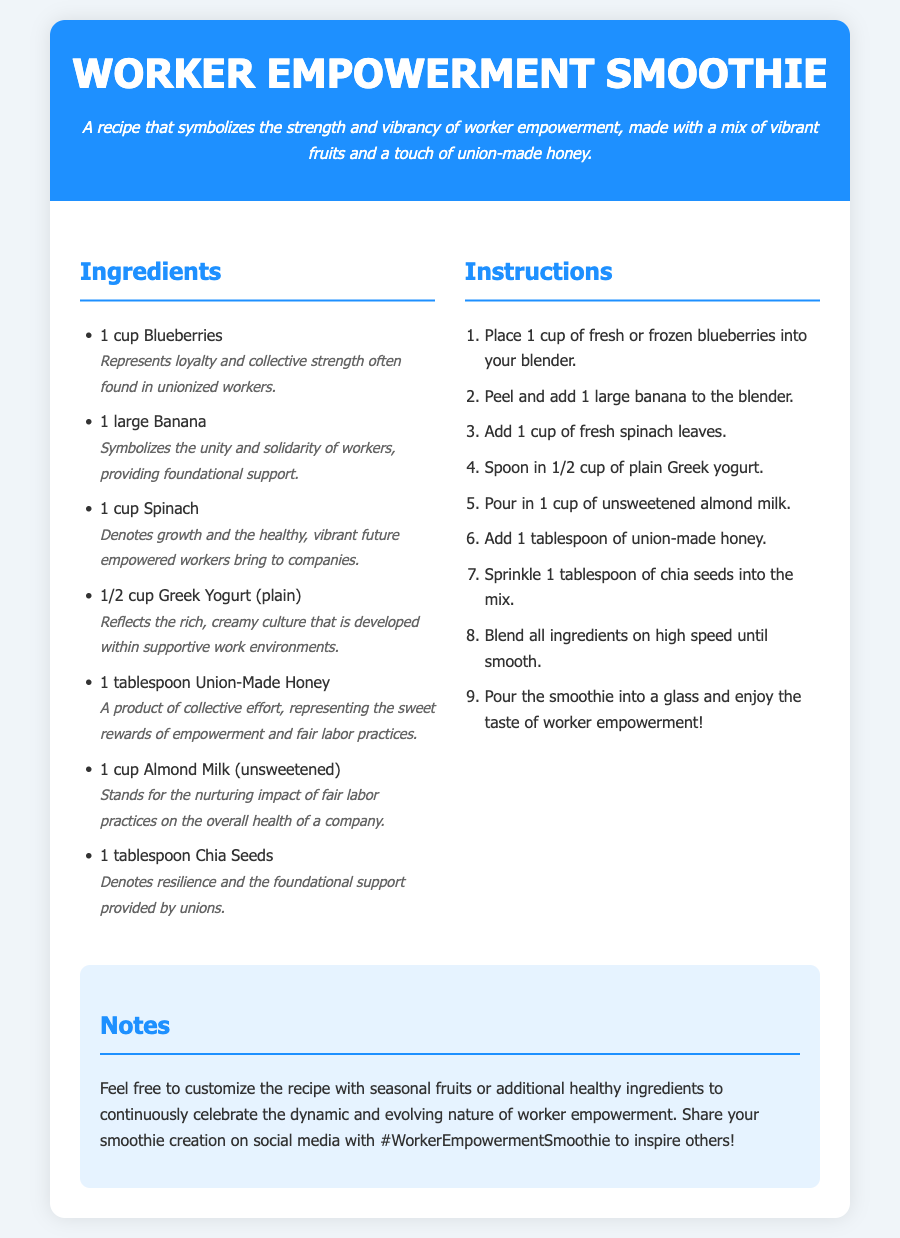What is the title of the recipe? The title of the recipe is displayed prominently at the top of the document.
Answer: Worker Empowerment Smoothie How many ingredients are listed in the recipe? The ingredients are enumerated in a list, which can be counted for the total.
Answer: 7 What ingredient symbolizes unity and solidarity? The symbolism for unity and solidarity is provided for one of the ingredients in the list.
Answer: Banana What does union-made honey represent in the recipe? The symbolism for the honey is explained in context within the ingredient section.
Answer: Sweet rewards of empowerment and fair labor practices What is the maximum width of the recipe card? The maximum width is specified in the styles of the recipe card setup.
Answer: 800px Which ingredient reflects the culture in supportive work environments? The description of the Greek yogurt provides the cultural analogy.
Answer: Greek Yogurt (plain) What does spinach denote in the recipe? The symbolic meaning attributed to spinach is found in the ingredient's description.
Answer: Growth and healthy, vibrant future What should you sprinkle into the smoothie as a final ingredient? The final ingredient is detailed in the instructions which lists what to add before blending.
Answer: Chia Seeds What is suggested for customizing the recipe? The notes section provides ideas for personalizing the recipe.
Answer: Seasonal fruits or additional healthy ingredients 